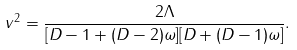<formula> <loc_0><loc_0><loc_500><loc_500>v ^ { 2 } = \frac { 2 \Lambda } { [ D - 1 + ( D - 2 ) \omega ] [ D + ( D - 1 ) \omega ] } .</formula> 